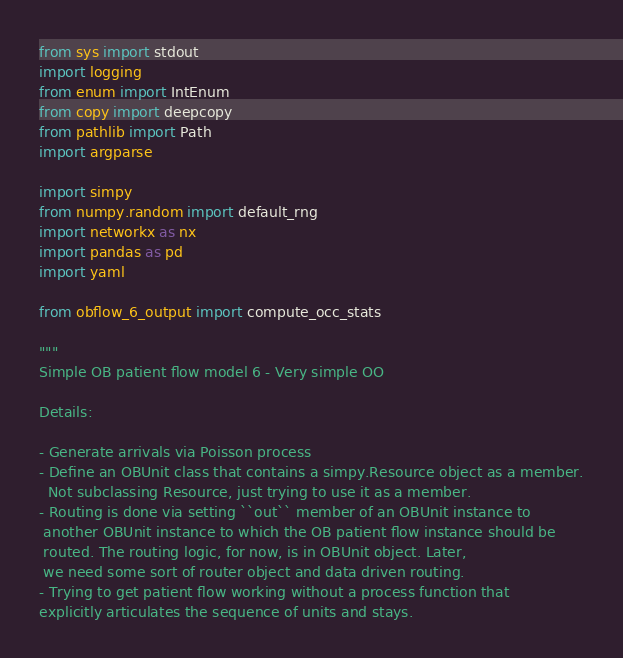Convert code to text. <code><loc_0><loc_0><loc_500><loc_500><_Python_>from sys import stdout
import logging
from enum import IntEnum
from copy import deepcopy
from pathlib import Path
import argparse

import simpy
from numpy.random import default_rng
import networkx as nx
import pandas as pd
import yaml

from obflow_6_output import compute_occ_stats

"""
Simple OB patient flow model 6 - Very simple OO

Details:

- Generate arrivals via Poisson process
- Define an OBUnit class that contains a simpy.Resource object as a member.
  Not subclassing Resource, just trying to use it as a member.
- Routing is done via setting ``out`` member of an OBUnit instance to
 another OBUnit instance to which the OB patient flow instance should be
 routed. The routing logic, for now, is in OBUnit object. Later,
 we need some sort of router object and data driven routing.
- Trying to get patient flow working without a process function that
explicitly articulates the sequence of units and stays.
</code> 